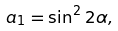Convert formula to latex. <formula><loc_0><loc_0><loc_500><loc_500>a _ { 1 } = \sin ^ { 2 } 2 \alpha ,</formula> 